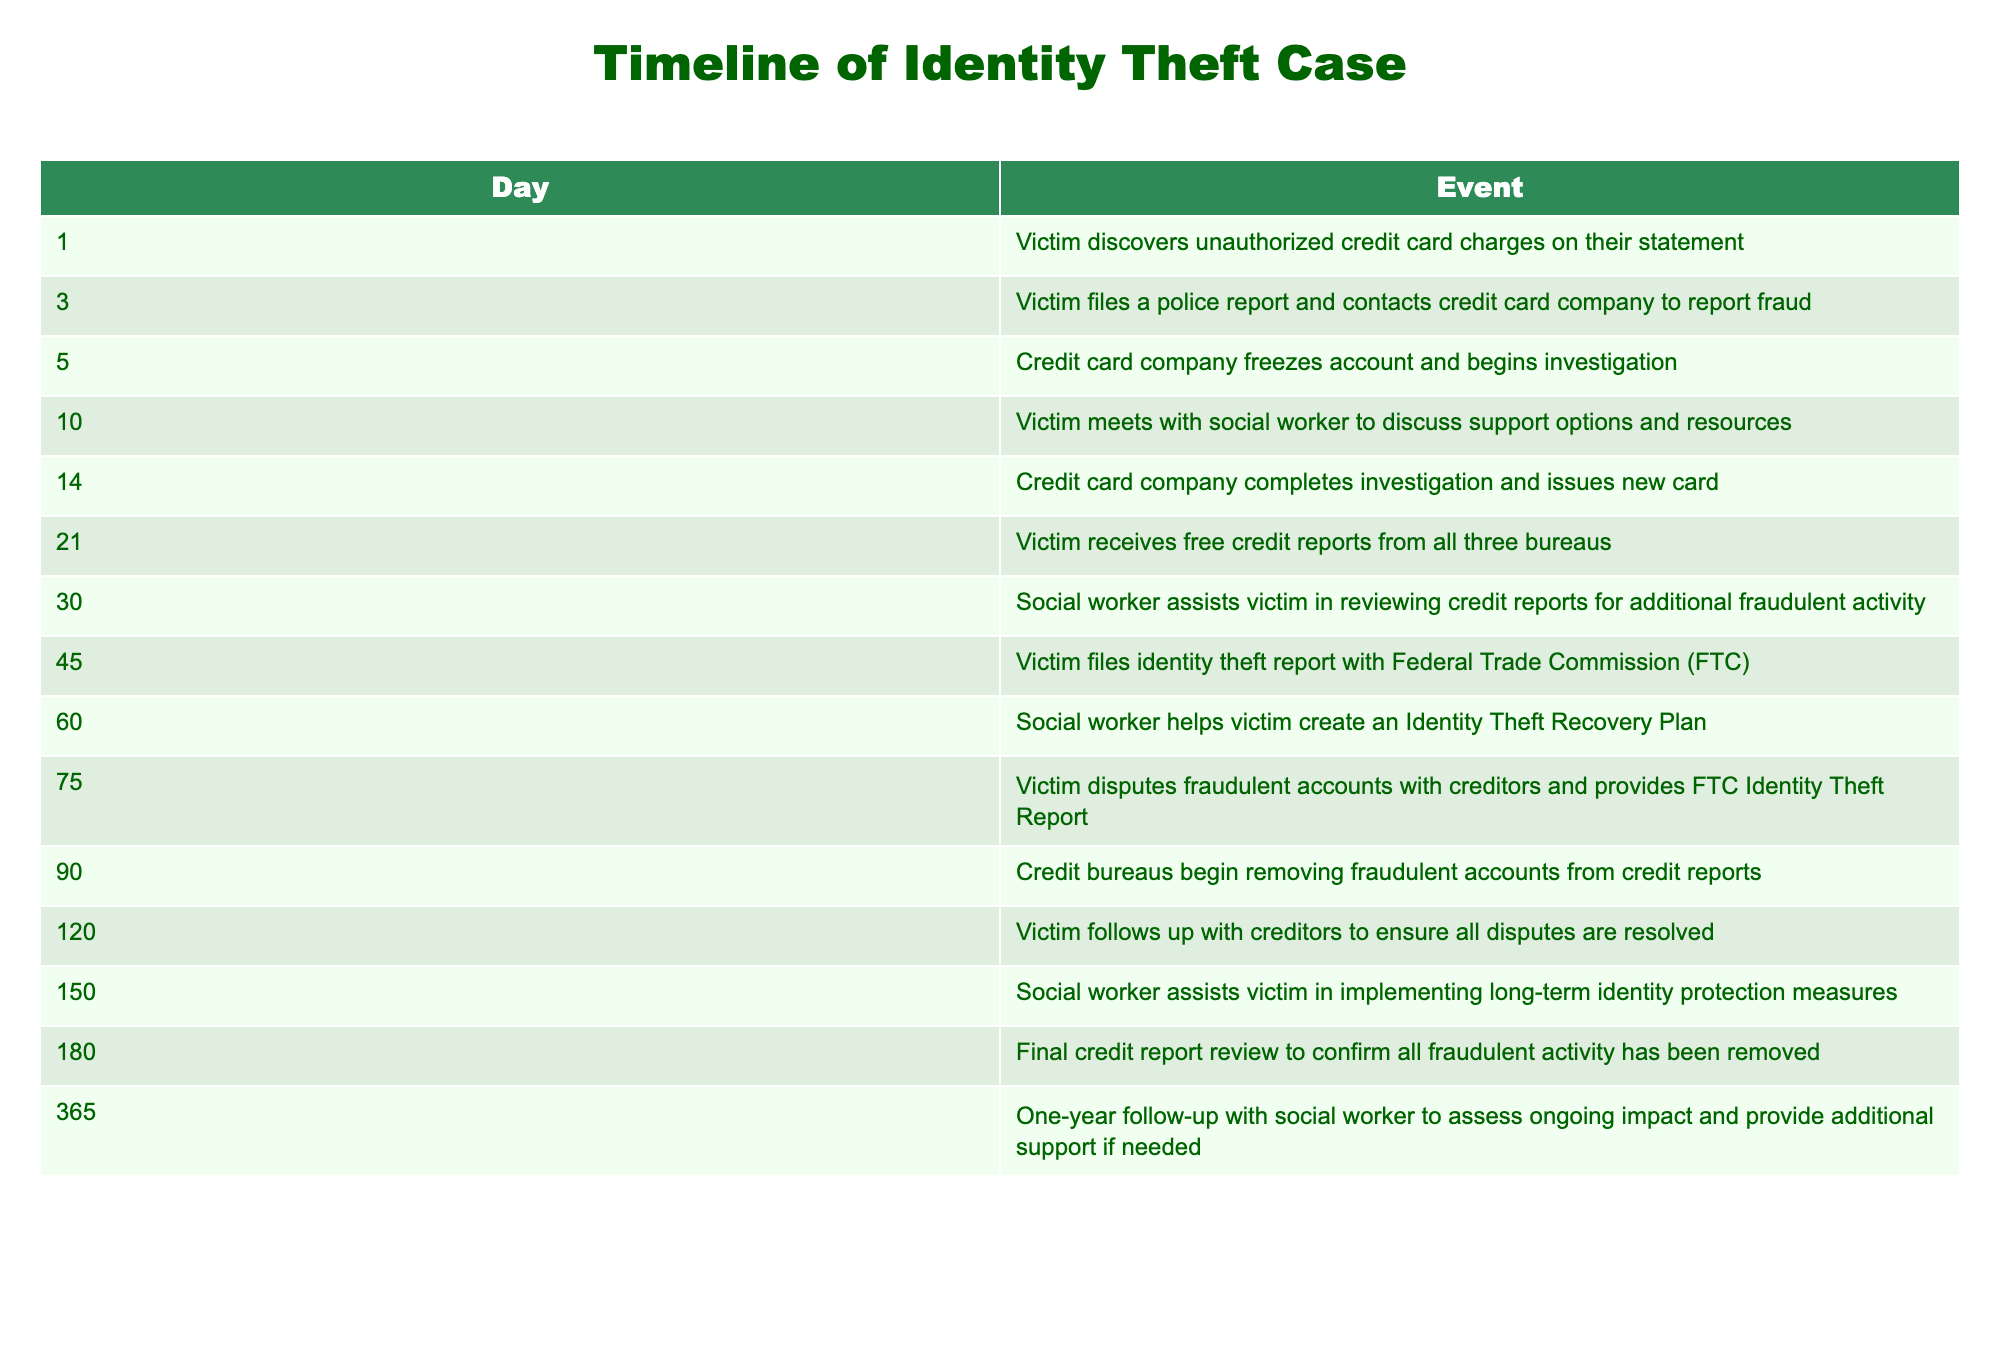What event happens on day 1? The table lists the specific events that occur throughout the timeline of an identity theft case. On day 1, the event mentioned is when the victim discovers unauthorized credit card charges on their statement.
Answer: Victim discovers unauthorized credit card charges on their statement How many days pass before the victim meets with a social worker? To determine the number of days that pass before the victim meets with a social worker, we should subtract the day of the meeting (day 10) from the day of the first event (day 1). This gives us a difference of 10 - 1 = 9 days.
Answer: 9 Did the credit card company issue a new card before completing their investigation? According to the timeline, the credit card company completes their investigation on day 14 and issues a new card on the same day. This means the new card is not issued before completing the investigation, confirming that this statement is false.
Answer: No What is the total number of days from the initial discovery of fraud to the follow-up with the social worker? To find the total number of days, we look at the final event, which is the follow-up with the social worker that happens on day 365. The initial discovery occurs on day 1. The total number of days is 365 - 1 + 1 = 365 days. Thus, from the initial discovery to the follow-up, it's a full year.
Answer: 365 On which day does the victim file an identity theft report with the FTC? The table states that the victim files an identity theft report with the Federal Trade Commission on day 45.
Answer: Day 45 How many events occur before the victim receives free credit reports? The event of receiving free credit reports occurs on day 21. We look at the previous events listed in the table that occur before this day, which are 5 events (days 1, 3, 5, 10, and 14).
Answer: 5 Is there a social worker's involvement on every significant day listed in the timeline? By looking at the timeline, social worker involvement is noted on days 10, 30, 60, and 150. Since there are days (like 1, 3, 5, 14, etc.) without social worker involvement, the statement is false.
Answer: No What is the average time (in days) between filing the police report and receiving the new credit card? The police report is filed on day 3, and the new credit card is issued on day 14. The time between these two events is 14 - 3 = 11 days. To find the average time taken, since there's only one period, the average is also 11 days.
Answer: 11 